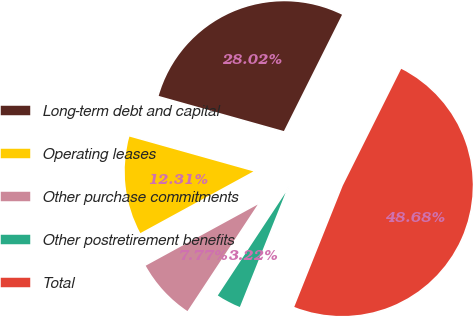Convert chart to OTSL. <chart><loc_0><loc_0><loc_500><loc_500><pie_chart><fcel>Long-term debt and capital<fcel>Operating leases<fcel>Other purchase commitments<fcel>Other postretirement benefits<fcel>Total<nl><fcel>28.02%<fcel>12.31%<fcel>7.77%<fcel>3.22%<fcel>48.68%<nl></chart> 